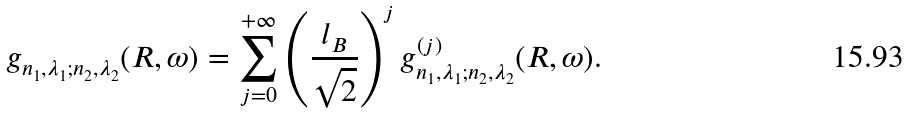Convert formula to latex. <formula><loc_0><loc_0><loc_500><loc_500>g _ { n _ { 1 } , \lambda _ { 1 } ; n _ { 2 } , \lambda _ { 2 } } ( R , \omega ) = \sum _ { j = 0 } ^ { + \infty } \left ( \frac { l _ { B } } { \sqrt { 2 } } \right ) ^ { j } g ^ { ( j ) } _ { n _ { 1 } , \lambda _ { 1 } ; n _ { 2 } , \lambda _ { 2 } } ( R , \omega ) .</formula> 